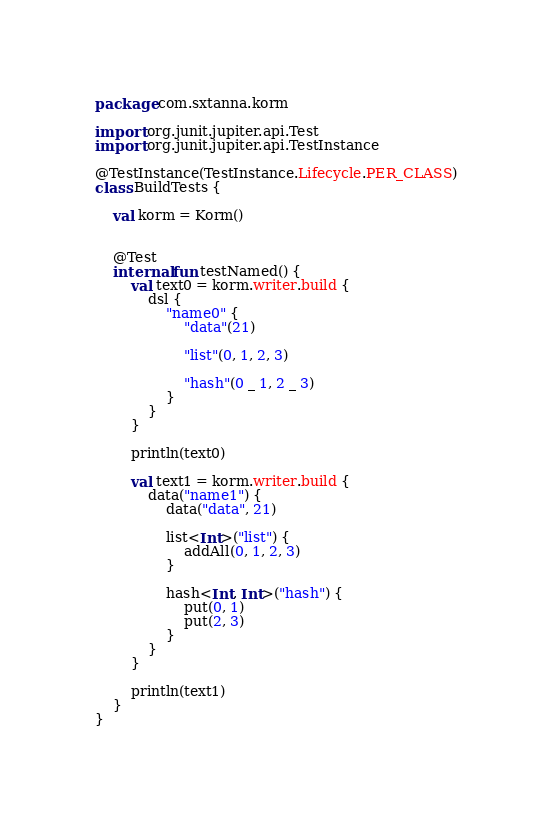Convert code to text. <code><loc_0><loc_0><loc_500><loc_500><_Kotlin_>package com.sxtanna.korm

import org.junit.jupiter.api.Test
import org.junit.jupiter.api.TestInstance

@TestInstance(TestInstance.Lifecycle.PER_CLASS)
class BuildTests {

    val korm = Korm()


    @Test
    internal fun testNamed() {
        val text0 = korm.writer.build {
            dsl {
                "name0" {
                    "data"(21)

                    "list"(0, 1, 2, 3)

                    "hash"(0 _ 1, 2 _ 3)
                }
            }
        }

        println(text0)

        val text1 = korm.writer.build {
            data("name1") {
                data("data", 21)

                list<Int>("list") {
                    addAll(0, 1, 2, 3)
                }

                hash<Int, Int>("hash") {
                    put(0, 1)
                    put(2, 3)
                }
            }
        }

        println(text1)
    }
}</code> 